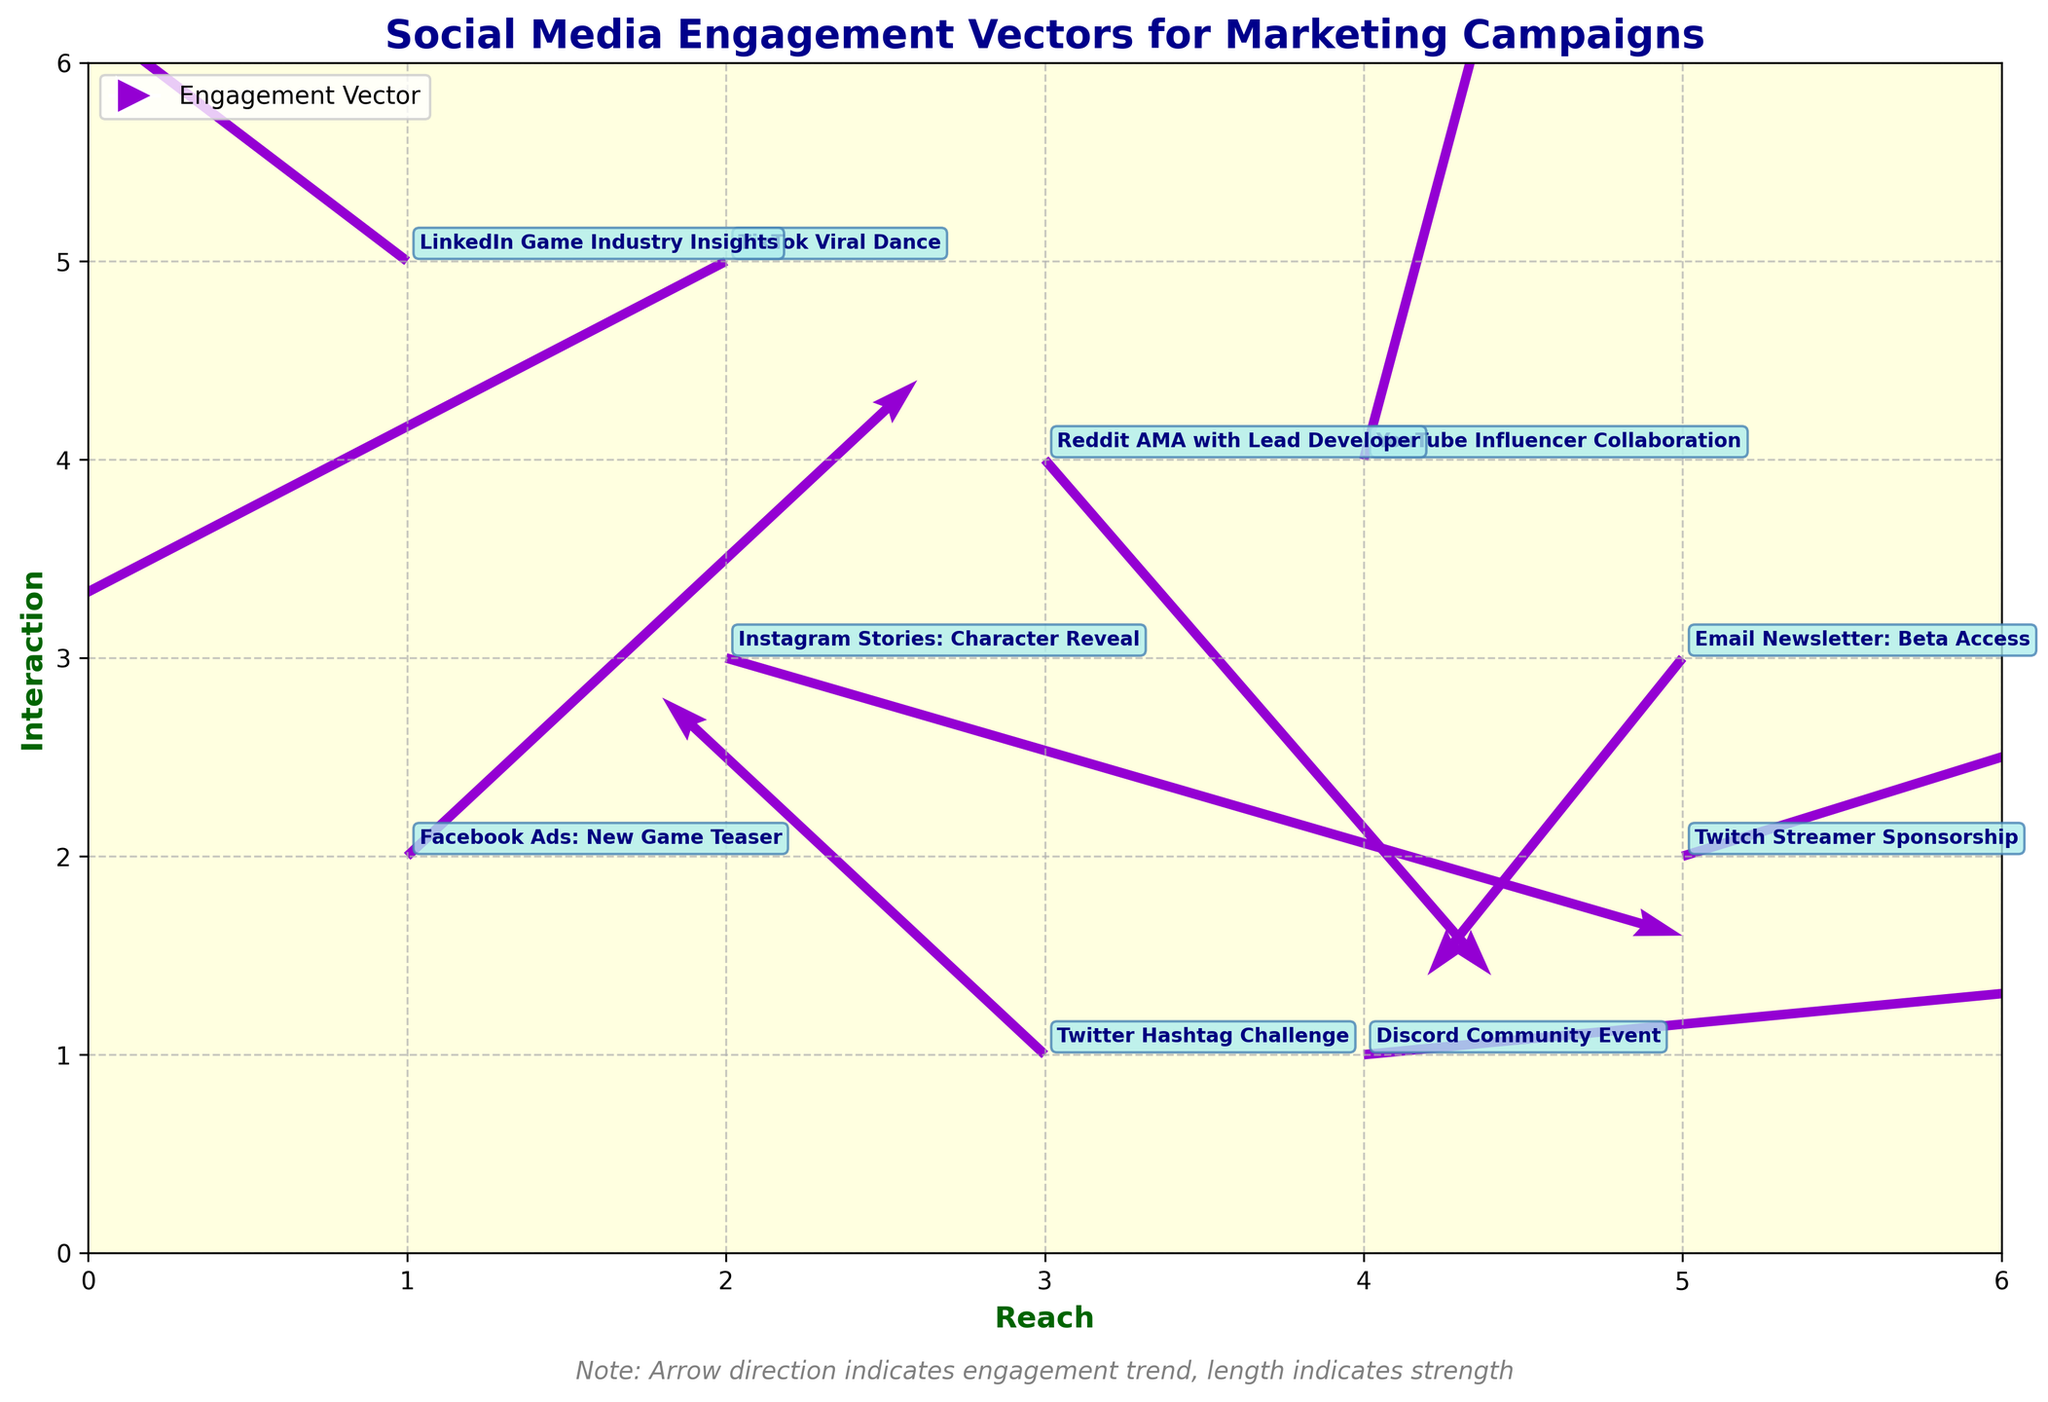What is the title of the figure? The title is located at the top of the figure and readable at first glance. It is written in dark blue, bold font.
Answer: Social Media Engagement Vectors for Marketing Campaigns What are the labels for the x-axis and y-axis? The labels are found along the horizontal (x-axis) and vertical (y-axis) edges of the plot, written in bold, dark green font.
Answer: x-axis: Reach, y-axis: Interaction Which campaign shows the strongest positive engagement trend in both reach and interaction? Identify the vector that is longest and pointing in the positive direction for both axes. The vector starting at (1, 2) and pointing (0.8, 1.2) indicates the strongest positive trend.
Answer: Facebook Ads: New Game Teaser Which campaign has a negative interaction vector but positive reach vector? Examine vectors with negative v (interaction) and positive u (reach). The vector starting at (2, 3) with (1.5, -0.7) fits this description.
Answer: Instagram Stories: Character Reveal Which campaign has the highest starting interaction value? Compare the starting y-values of all campaigns to see which is the highest. The campaign starting at y=5 is the highest.
Answer: LinkedIn Game Industry Insights & TikTok Viral Dance Of all the campaigns, which one has the most negative engagement in both reach and interaction? Look for the vector with the largest negative values for both components u (reach) and v (interaction). The vector (2, 5) with (-1.2, -1.0) shows this.
Answer: TikTok Viral Dance How many campaigns have their vectors starting with a reach (x-value) between 3 and 4? Count the number of vectors starting in the range of x between 3 and 4. There are vectors at x=3 and x=4.
Answer: Three campaigns Comparing the YouTube Influencer Collaboration and Reddit AMA with Lead Developer, which campaign saw a higher increase in interaction based on vector length? Compare the v-values for both campaigns. The YouTube vector (4, 4) with (0.3, 1.8) has a higher interaction increase than Reddit's (3, 4) with (0.7, -1.3).
Answer: YouTube Influencer Collaboration Which campaign has the shortest vector in terms of engagement change (combined reach and interaction)? Calculate the Euclidean length of each vector (u, v) and compare. The shortest vector based on length √(0.3² + 1.8²) belongs to the YouTube Influencer Collaboration.
Answer: YouTube Influencer Collaboration 